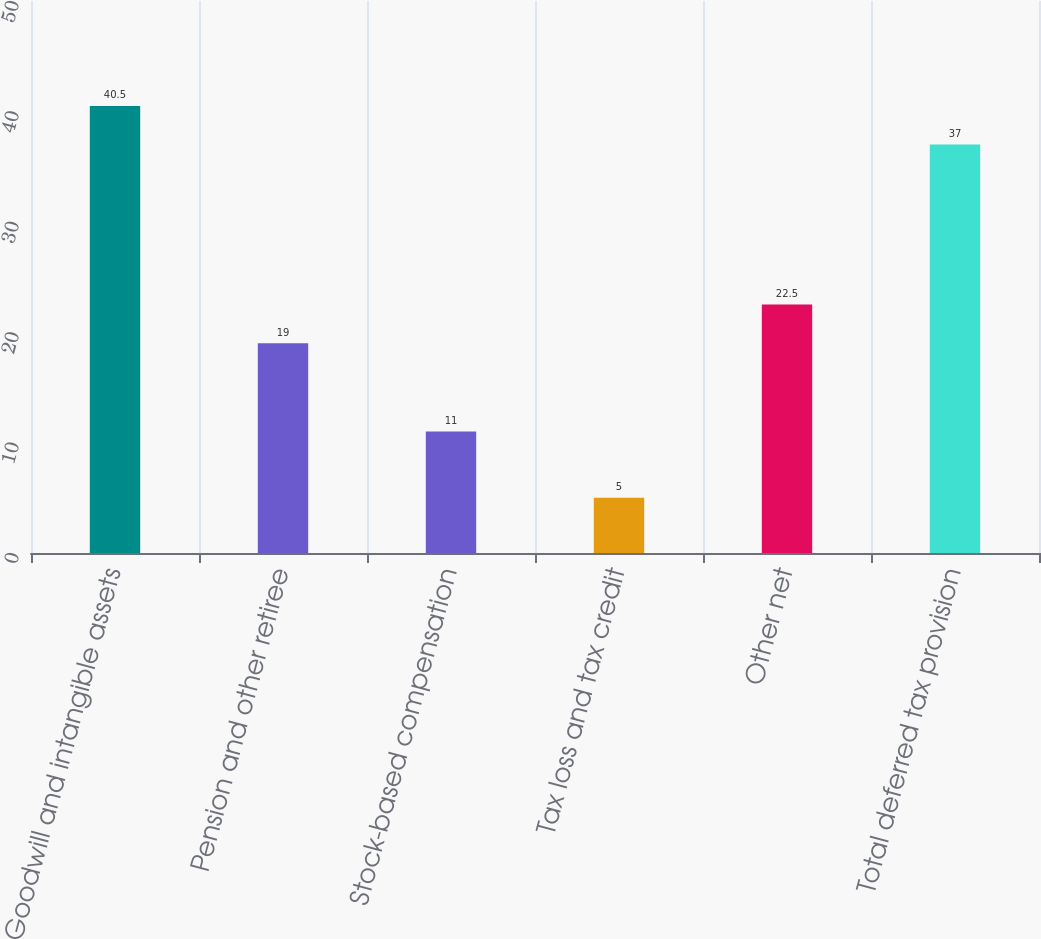<chart> <loc_0><loc_0><loc_500><loc_500><bar_chart><fcel>Goodwill and intangible assets<fcel>Pension and other retiree<fcel>Stock-based compensation<fcel>Tax loss and tax credit<fcel>Other net<fcel>Total deferred tax provision<nl><fcel>40.5<fcel>19<fcel>11<fcel>5<fcel>22.5<fcel>37<nl></chart> 